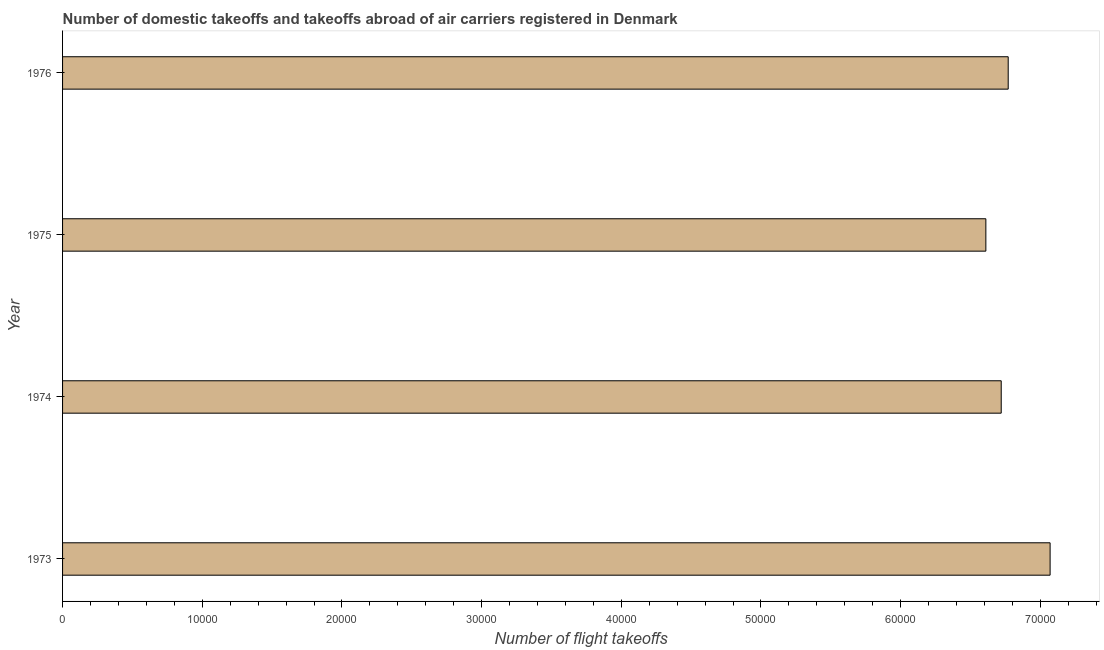Does the graph contain any zero values?
Your answer should be very brief. No. Does the graph contain grids?
Give a very brief answer. No. What is the title of the graph?
Your answer should be compact. Number of domestic takeoffs and takeoffs abroad of air carriers registered in Denmark. What is the label or title of the X-axis?
Offer a very short reply. Number of flight takeoffs. What is the label or title of the Y-axis?
Your answer should be very brief. Year. What is the number of flight takeoffs in 1976?
Keep it short and to the point. 6.77e+04. Across all years, what is the maximum number of flight takeoffs?
Keep it short and to the point. 7.07e+04. Across all years, what is the minimum number of flight takeoffs?
Provide a short and direct response. 6.61e+04. In which year was the number of flight takeoffs maximum?
Offer a very short reply. 1973. In which year was the number of flight takeoffs minimum?
Make the answer very short. 1975. What is the sum of the number of flight takeoffs?
Make the answer very short. 2.72e+05. What is the difference between the number of flight takeoffs in 1973 and 1976?
Your answer should be very brief. 3000. What is the average number of flight takeoffs per year?
Make the answer very short. 6.79e+04. What is the median number of flight takeoffs?
Provide a short and direct response. 6.74e+04. In how many years, is the number of flight takeoffs greater than 20000 ?
Give a very brief answer. 4. Is the number of flight takeoffs in 1973 less than that in 1976?
Your answer should be very brief. No. What is the difference between the highest and the second highest number of flight takeoffs?
Your answer should be compact. 3000. What is the difference between the highest and the lowest number of flight takeoffs?
Your response must be concise. 4600. In how many years, is the number of flight takeoffs greater than the average number of flight takeoffs taken over all years?
Provide a succinct answer. 1. How many bars are there?
Your answer should be compact. 4. Are all the bars in the graph horizontal?
Provide a succinct answer. Yes. How many years are there in the graph?
Your response must be concise. 4. What is the Number of flight takeoffs in 1973?
Your answer should be compact. 7.07e+04. What is the Number of flight takeoffs in 1974?
Provide a short and direct response. 6.72e+04. What is the Number of flight takeoffs of 1975?
Your answer should be compact. 6.61e+04. What is the Number of flight takeoffs in 1976?
Provide a succinct answer. 6.77e+04. What is the difference between the Number of flight takeoffs in 1973 and 1974?
Offer a terse response. 3500. What is the difference between the Number of flight takeoffs in 1973 and 1975?
Keep it short and to the point. 4600. What is the difference between the Number of flight takeoffs in 1973 and 1976?
Provide a succinct answer. 3000. What is the difference between the Number of flight takeoffs in 1974 and 1975?
Provide a short and direct response. 1100. What is the difference between the Number of flight takeoffs in 1974 and 1976?
Give a very brief answer. -500. What is the difference between the Number of flight takeoffs in 1975 and 1976?
Your answer should be compact. -1600. What is the ratio of the Number of flight takeoffs in 1973 to that in 1974?
Provide a short and direct response. 1.05. What is the ratio of the Number of flight takeoffs in 1973 to that in 1975?
Keep it short and to the point. 1.07. What is the ratio of the Number of flight takeoffs in 1973 to that in 1976?
Offer a terse response. 1.04. What is the ratio of the Number of flight takeoffs in 1975 to that in 1976?
Make the answer very short. 0.98. 